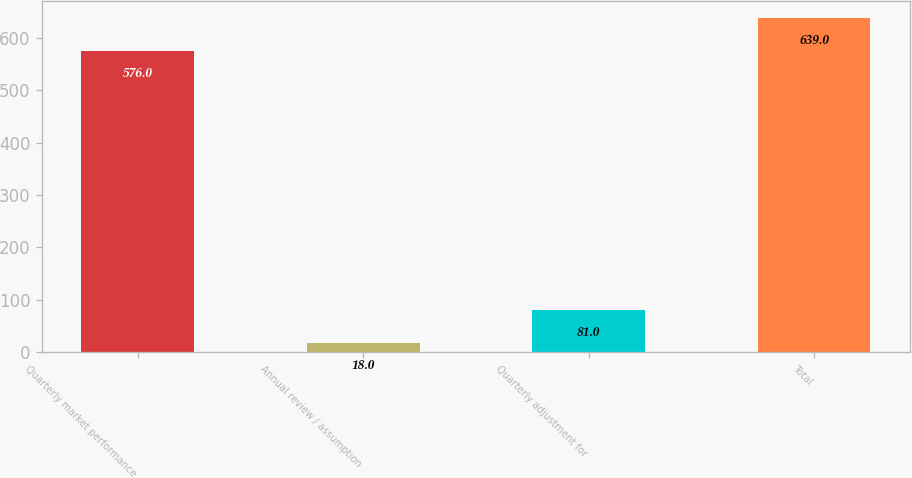Convert chart. <chart><loc_0><loc_0><loc_500><loc_500><bar_chart><fcel>Quarterly market performance<fcel>Annual review / assumption<fcel>Quarterly adjustment for<fcel>Total<nl><fcel>576<fcel>18<fcel>81<fcel>639<nl></chart> 